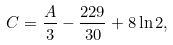<formula> <loc_0><loc_0><loc_500><loc_500>C = \frac { A } { 3 } - \frac { 2 2 9 } { 3 0 } + 8 \ln 2 ,</formula> 